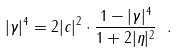<formula> <loc_0><loc_0><loc_500><loc_500>| \gamma | ^ { 4 } = 2 | c | ^ { 2 } \cdot \frac { 1 - | \gamma | ^ { 4 } } { 1 + 2 | \eta | ^ { 2 } } \ .</formula> 